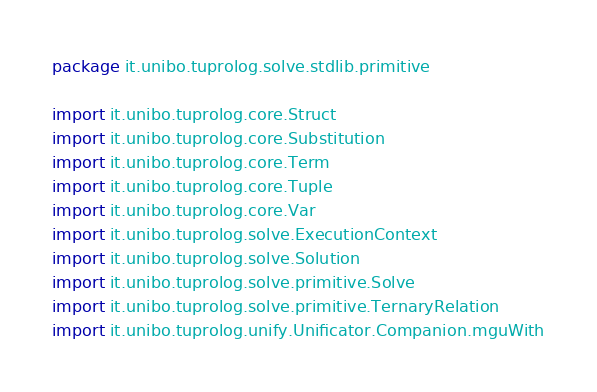<code> <loc_0><loc_0><loc_500><loc_500><_Kotlin_>package it.unibo.tuprolog.solve.stdlib.primitive

import it.unibo.tuprolog.core.Struct
import it.unibo.tuprolog.core.Substitution
import it.unibo.tuprolog.core.Term
import it.unibo.tuprolog.core.Tuple
import it.unibo.tuprolog.core.Var
import it.unibo.tuprolog.solve.ExecutionContext
import it.unibo.tuprolog.solve.Solution
import it.unibo.tuprolog.solve.primitive.Solve
import it.unibo.tuprolog.solve.primitive.TernaryRelation
import it.unibo.tuprolog.unify.Unificator.Companion.mguWith</code> 